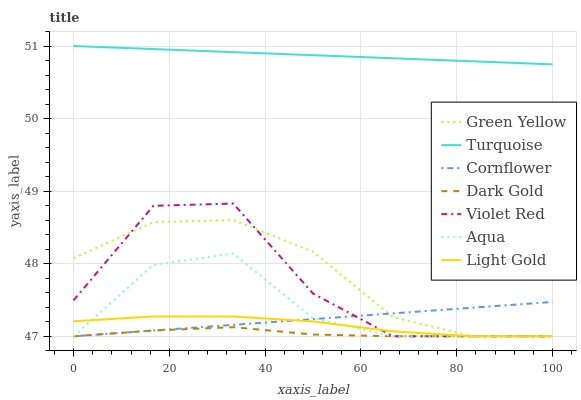Does Dark Gold have the minimum area under the curve?
Answer yes or no. Yes. Does Turquoise have the maximum area under the curve?
Answer yes or no. Yes. Does Turquoise have the minimum area under the curve?
Answer yes or no. No. Does Dark Gold have the maximum area under the curve?
Answer yes or no. No. Is Cornflower the smoothest?
Answer yes or no. Yes. Is Violet Red the roughest?
Answer yes or no. Yes. Is Turquoise the smoothest?
Answer yes or no. No. Is Turquoise the roughest?
Answer yes or no. No. Does Cornflower have the lowest value?
Answer yes or no. Yes. Does Turquoise have the lowest value?
Answer yes or no. No. Does Turquoise have the highest value?
Answer yes or no. Yes. Does Dark Gold have the highest value?
Answer yes or no. No. Is Aqua less than Turquoise?
Answer yes or no. Yes. Is Turquoise greater than Light Gold?
Answer yes or no. Yes. Does Dark Gold intersect Violet Red?
Answer yes or no. Yes. Is Dark Gold less than Violet Red?
Answer yes or no. No. Is Dark Gold greater than Violet Red?
Answer yes or no. No. Does Aqua intersect Turquoise?
Answer yes or no. No. 